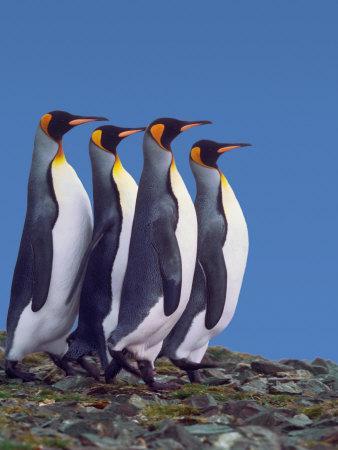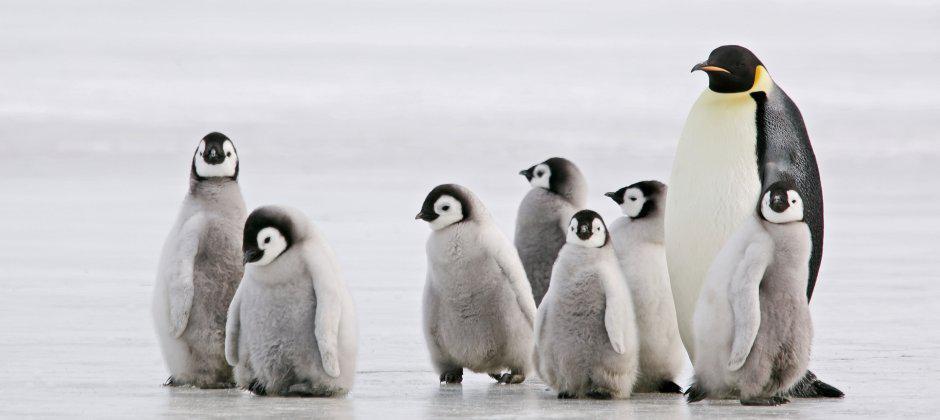The first image is the image on the left, the second image is the image on the right. Given the left and right images, does the statement "In one of the images, all penguins are facing right." hold true? Answer yes or no. Yes. 